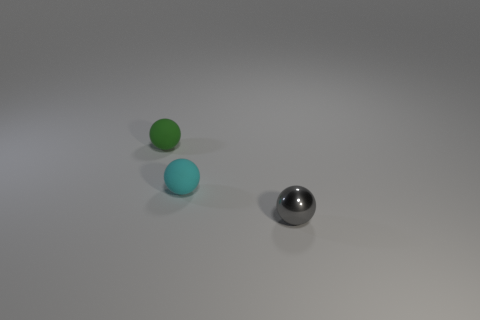Add 1 small green balls. How many objects exist? 4 Add 3 cyan things. How many cyan things exist? 4 Subtract 0 purple blocks. How many objects are left? 3 Subtract all tiny green matte things. Subtract all small gray things. How many objects are left? 1 Add 1 metal things. How many metal things are left? 2 